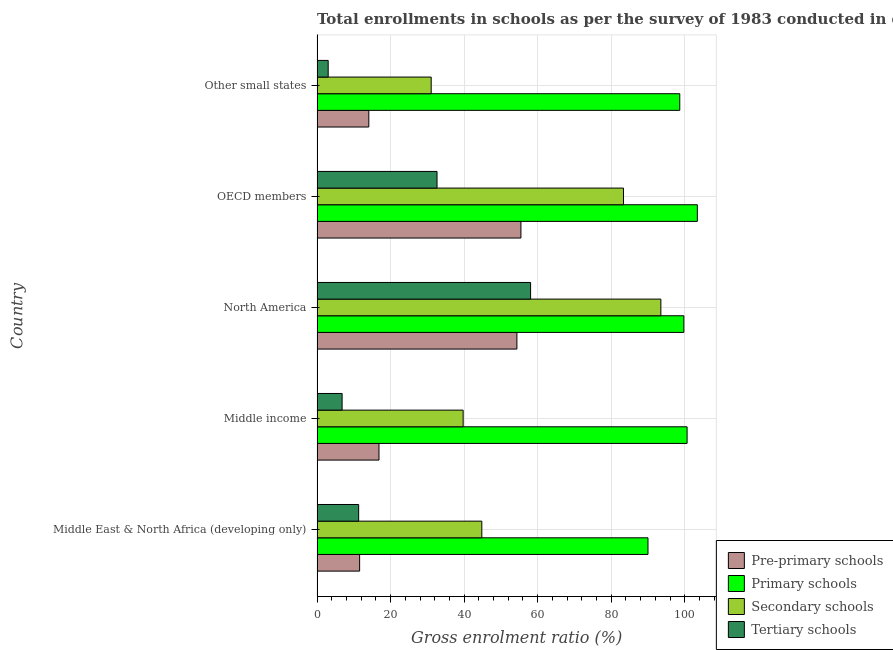How many groups of bars are there?
Make the answer very short. 5. Are the number of bars per tick equal to the number of legend labels?
Offer a very short reply. Yes. Are the number of bars on each tick of the Y-axis equal?
Provide a short and direct response. Yes. What is the label of the 1st group of bars from the top?
Your response must be concise. Other small states. What is the gross enrolment ratio in tertiary schools in Other small states?
Provide a short and direct response. 3.03. Across all countries, what is the maximum gross enrolment ratio in pre-primary schools?
Your response must be concise. 55.45. Across all countries, what is the minimum gross enrolment ratio in tertiary schools?
Keep it short and to the point. 3.03. In which country was the gross enrolment ratio in tertiary schools minimum?
Your answer should be very brief. Other small states. What is the total gross enrolment ratio in secondary schools in the graph?
Keep it short and to the point. 292.43. What is the difference between the gross enrolment ratio in tertiary schools in Middle income and that in North America?
Your answer should be very brief. -51.26. What is the difference between the gross enrolment ratio in pre-primary schools in OECD members and the gross enrolment ratio in primary schools in Middle East & North Africa (developing only)?
Give a very brief answer. -34.56. What is the average gross enrolment ratio in tertiary schools per country?
Offer a very short reply. 22.37. What is the difference between the gross enrolment ratio in secondary schools and gross enrolment ratio in primary schools in North America?
Offer a terse response. -6.25. In how many countries, is the gross enrolment ratio in tertiary schools greater than 32 %?
Keep it short and to the point. 2. What is the ratio of the gross enrolment ratio in pre-primary schools in North America to that in Other small states?
Keep it short and to the point. 3.86. Is the gross enrolment ratio in pre-primary schools in Middle income less than that in Other small states?
Make the answer very short. No. Is the difference between the gross enrolment ratio in primary schools in Middle East & North Africa (developing only) and OECD members greater than the difference between the gross enrolment ratio in secondary schools in Middle East & North Africa (developing only) and OECD members?
Make the answer very short. Yes. What is the difference between the highest and the second highest gross enrolment ratio in pre-primary schools?
Provide a succinct answer. 1.09. What is the difference between the highest and the lowest gross enrolment ratio in pre-primary schools?
Your answer should be compact. 43.87. Is the sum of the gross enrolment ratio in pre-primary schools in Middle East & North Africa (developing only) and Middle income greater than the maximum gross enrolment ratio in tertiary schools across all countries?
Ensure brevity in your answer.  No. Is it the case that in every country, the sum of the gross enrolment ratio in primary schools and gross enrolment ratio in tertiary schools is greater than the sum of gross enrolment ratio in secondary schools and gross enrolment ratio in pre-primary schools?
Ensure brevity in your answer.  No. What does the 3rd bar from the top in Middle income represents?
Offer a terse response. Primary schools. What does the 2nd bar from the bottom in North America represents?
Your response must be concise. Primary schools. Are the values on the major ticks of X-axis written in scientific E-notation?
Give a very brief answer. No. Does the graph contain grids?
Keep it short and to the point. Yes. How many legend labels are there?
Your answer should be compact. 4. How are the legend labels stacked?
Your response must be concise. Vertical. What is the title of the graph?
Your answer should be compact. Total enrollments in schools as per the survey of 1983 conducted in different countries. Does "UNPBF" appear as one of the legend labels in the graph?
Ensure brevity in your answer.  No. What is the label or title of the Y-axis?
Give a very brief answer. Country. What is the Gross enrolment ratio (%) of Pre-primary schools in Middle East & North Africa (developing only)?
Your answer should be very brief. 11.58. What is the Gross enrolment ratio (%) in Primary schools in Middle East & North Africa (developing only)?
Offer a terse response. 90. What is the Gross enrolment ratio (%) of Secondary schools in Middle East & North Africa (developing only)?
Make the answer very short. 44.81. What is the Gross enrolment ratio (%) in Tertiary schools in Middle East & North Africa (developing only)?
Your answer should be very brief. 11.32. What is the Gross enrolment ratio (%) in Pre-primary schools in Middle income?
Provide a succinct answer. 16.84. What is the Gross enrolment ratio (%) in Primary schools in Middle income?
Ensure brevity in your answer.  100.64. What is the Gross enrolment ratio (%) of Secondary schools in Middle income?
Ensure brevity in your answer.  39.73. What is the Gross enrolment ratio (%) in Tertiary schools in Middle income?
Offer a very short reply. 6.81. What is the Gross enrolment ratio (%) in Pre-primary schools in North America?
Keep it short and to the point. 54.36. What is the Gross enrolment ratio (%) in Primary schools in North America?
Provide a short and direct response. 99.76. What is the Gross enrolment ratio (%) of Secondary schools in North America?
Your answer should be very brief. 93.51. What is the Gross enrolment ratio (%) in Tertiary schools in North America?
Make the answer very short. 58.08. What is the Gross enrolment ratio (%) of Pre-primary schools in OECD members?
Provide a short and direct response. 55.45. What is the Gross enrolment ratio (%) in Primary schools in OECD members?
Provide a short and direct response. 103.43. What is the Gross enrolment ratio (%) of Secondary schools in OECD members?
Provide a succinct answer. 83.34. What is the Gross enrolment ratio (%) in Tertiary schools in OECD members?
Give a very brief answer. 32.63. What is the Gross enrolment ratio (%) of Pre-primary schools in Other small states?
Provide a short and direct response. 14.08. What is the Gross enrolment ratio (%) in Primary schools in Other small states?
Your answer should be very brief. 98.65. What is the Gross enrolment ratio (%) of Secondary schools in Other small states?
Make the answer very short. 31.04. What is the Gross enrolment ratio (%) in Tertiary schools in Other small states?
Ensure brevity in your answer.  3.03. Across all countries, what is the maximum Gross enrolment ratio (%) in Pre-primary schools?
Offer a terse response. 55.45. Across all countries, what is the maximum Gross enrolment ratio (%) in Primary schools?
Offer a terse response. 103.43. Across all countries, what is the maximum Gross enrolment ratio (%) of Secondary schools?
Your answer should be very brief. 93.51. Across all countries, what is the maximum Gross enrolment ratio (%) of Tertiary schools?
Your answer should be very brief. 58.08. Across all countries, what is the minimum Gross enrolment ratio (%) of Pre-primary schools?
Ensure brevity in your answer.  11.58. Across all countries, what is the minimum Gross enrolment ratio (%) in Primary schools?
Your response must be concise. 90. Across all countries, what is the minimum Gross enrolment ratio (%) of Secondary schools?
Your response must be concise. 31.04. Across all countries, what is the minimum Gross enrolment ratio (%) of Tertiary schools?
Give a very brief answer. 3.03. What is the total Gross enrolment ratio (%) of Pre-primary schools in the graph?
Make the answer very short. 152.3. What is the total Gross enrolment ratio (%) of Primary schools in the graph?
Your answer should be very brief. 492.48. What is the total Gross enrolment ratio (%) in Secondary schools in the graph?
Make the answer very short. 292.43. What is the total Gross enrolment ratio (%) of Tertiary schools in the graph?
Your answer should be very brief. 111.86. What is the difference between the Gross enrolment ratio (%) in Pre-primary schools in Middle East & North Africa (developing only) and that in Middle income?
Your answer should be very brief. -5.27. What is the difference between the Gross enrolment ratio (%) in Primary schools in Middle East & North Africa (developing only) and that in Middle income?
Give a very brief answer. -10.64. What is the difference between the Gross enrolment ratio (%) in Secondary schools in Middle East & North Africa (developing only) and that in Middle income?
Your response must be concise. 5.08. What is the difference between the Gross enrolment ratio (%) in Tertiary schools in Middle East & North Africa (developing only) and that in Middle income?
Provide a short and direct response. 4.5. What is the difference between the Gross enrolment ratio (%) of Pre-primary schools in Middle East & North Africa (developing only) and that in North America?
Ensure brevity in your answer.  -42.78. What is the difference between the Gross enrolment ratio (%) in Primary schools in Middle East & North Africa (developing only) and that in North America?
Provide a short and direct response. -9.75. What is the difference between the Gross enrolment ratio (%) of Secondary schools in Middle East & North Africa (developing only) and that in North America?
Your response must be concise. -48.7. What is the difference between the Gross enrolment ratio (%) in Tertiary schools in Middle East & North Africa (developing only) and that in North America?
Your answer should be compact. -46.76. What is the difference between the Gross enrolment ratio (%) of Pre-primary schools in Middle East & North Africa (developing only) and that in OECD members?
Give a very brief answer. -43.87. What is the difference between the Gross enrolment ratio (%) in Primary schools in Middle East & North Africa (developing only) and that in OECD members?
Provide a short and direct response. -13.42. What is the difference between the Gross enrolment ratio (%) of Secondary schools in Middle East & North Africa (developing only) and that in OECD members?
Provide a succinct answer. -38.53. What is the difference between the Gross enrolment ratio (%) of Tertiary schools in Middle East & North Africa (developing only) and that in OECD members?
Offer a terse response. -21.31. What is the difference between the Gross enrolment ratio (%) of Pre-primary schools in Middle East & North Africa (developing only) and that in Other small states?
Keep it short and to the point. -2.5. What is the difference between the Gross enrolment ratio (%) in Primary schools in Middle East & North Africa (developing only) and that in Other small states?
Ensure brevity in your answer.  -8.64. What is the difference between the Gross enrolment ratio (%) in Secondary schools in Middle East & North Africa (developing only) and that in Other small states?
Ensure brevity in your answer.  13.77. What is the difference between the Gross enrolment ratio (%) in Tertiary schools in Middle East & North Africa (developing only) and that in Other small states?
Your answer should be compact. 8.29. What is the difference between the Gross enrolment ratio (%) in Pre-primary schools in Middle income and that in North America?
Your answer should be compact. -37.51. What is the difference between the Gross enrolment ratio (%) in Primary schools in Middle income and that in North America?
Offer a very short reply. 0.88. What is the difference between the Gross enrolment ratio (%) of Secondary schools in Middle income and that in North America?
Offer a terse response. -53.78. What is the difference between the Gross enrolment ratio (%) of Tertiary schools in Middle income and that in North America?
Your answer should be compact. -51.26. What is the difference between the Gross enrolment ratio (%) of Pre-primary schools in Middle income and that in OECD members?
Ensure brevity in your answer.  -38.6. What is the difference between the Gross enrolment ratio (%) of Primary schools in Middle income and that in OECD members?
Your answer should be compact. -2.79. What is the difference between the Gross enrolment ratio (%) of Secondary schools in Middle income and that in OECD members?
Keep it short and to the point. -43.61. What is the difference between the Gross enrolment ratio (%) in Tertiary schools in Middle income and that in OECD members?
Provide a succinct answer. -25.82. What is the difference between the Gross enrolment ratio (%) in Pre-primary schools in Middle income and that in Other small states?
Your answer should be very brief. 2.77. What is the difference between the Gross enrolment ratio (%) of Primary schools in Middle income and that in Other small states?
Offer a terse response. 1.99. What is the difference between the Gross enrolment ratio (%) in Secondary schools in Middle income and that in Other small states?
Your answer should be very brief. 8.69. What is the difference between the Gross enrolment ratio (%) in Tertiary schools in Middle income and that in Other small states?
Give a very brief answer. 3.79. What is the difference between the Gross enrolment ratio (%) of Pre-primary schools in North America and that in OECD members?
Give a very brief answer. -1.09. What is the difference between the Gross enrolment ratio (%) of Primary schools in North America and that in OECD members?
Provide a succinct answer. -3.67. What is the difference between the Gross enrolment ratio (%) of Secondary schools in North America and that in OECD members?
Offer a terse response. 10.17. What is the difference between the Gross enrolment ratio (%) in Tertiary schools in North America and that in OECD members?
Offer a terse response. 25.45. What is the difference between the Gross enrolment ratio (%) of Pre-primary schools in North America and that in Other small states?
Provide a succinct answer. 40.28. What is the difference between the Gross enrolment ratio (%) in Primary schools in North America and that in Other small states?
Your response must be concise. 1.11. What is the difference between the Gross enrolment ratio (%) of Secondary schools in North America and that in Other small states?
Provide a succinct answer. 62.46. What is the difference between the Gross enrolment ratio (%) of Tertiary schools in North America and that in Other small states?
Your answer should be very brief. 55.05. What is the difference between the Gross enrolment ratio (%) in Pre-primary schools in OECD members and that in Other small states?
Your response must be concise. 41.37. What is the difference between the Gross enrolment ratio (%) of Primary schools in OECD members and that in Other small states?
Offer a very short reply. 4.78. What is the difference between the Gross enrolment ratio (%) in Secondary schools in OECD members and that in Other small states?
Your response must be concise. 52.3. What is the difference between the Gross enrolment ratio (%) of Tertiary schools in OECD members and that in Other small states?
Keep it short and to the point. 29.6. What is the difference between the Gross enrolment ratio (%) of Pre-primary schools in Middle East & North Africa (developing only) and the Gross enrolment ratio (%) of Primary schools in Middle income?
Make the answer very short. -89.06. What is the difference between the Gross enrolment ratio (%) in Pre-primary schools in Middle East & North Africa (developing only) and the Gross enrolment ratio (%) in Secondary schools in Middle income?
Give a very brief answer. -28.15. What is the difference between the Gross enrolment ratio (%) in Pre-primary schools in Middle East & North Africa (developing only) and the Gross enrolment ratio (%) in Tertiary schools in Middle income?
Give a very brief answer. 4.76. What is the difference between the Gross enrolment ratio (%) of Primary schools in Middle East & North Africa (developing only) and the Gross enrolment ratio (%) of Secondary schools in Middle income?
Your answer should be compact. 50.27. What is the difference between the Gross enrolment ratio (%) of Primary schools in Middle East & North Africa (developing only) and the Gross enrolment ratio (%) of Tertiary schools in Middle income?
Provide a succinct answer. 83.19. What is the difference between the Gross enrolment ratio (%) in Secondary schools in Middle East & North Africa (developing only) and the Gross enrolment ratio (%) in Tertiary schools in Middle income?
Provide a succinct answer. 38. What is the difference between the Gross enrolment ratio (%) in Pre-primary schools in Middle East & North Africa (developing only) and the Gross enrolment ratio (%) in Primary schools in North America?
Make the answer very short. -88.18. What is the difference between the Gross enrolment ratio (%) of Pre-primary schools in Middle East & North Africa (developing only) and the Gross enrolment ratio (%) of Secondary schools in North America?
Your response must be concise. -81.93. What is the difference between the Gross enrolment ratio (%) of Pre-primary schools in Middle East & North Africa (developing only) and the Gross enrolment ratio (%) of Tertiary schools in North America?
Your answer should be compact. -46.5. What is the difference between the Gross enrolment ratio (%) in Primary schools in Middle East & North Africa (developing only) and the Gross enrolment ratio (%) in Secondary schools in North America?
Your response must be concise. -3.5. What is the difference between the Gross enrolment ratio (%) of Primary schools in Middle East & North Africa (developing only) and the Gross enrolment ratio (%) of Tertiary schools in North America?
Provide a short and direct response. 31.93. What is the difference between the Gross enrolment ratio (%) of Secondary schools in Middle East & North Africa (developing only) and the Gross enrolment ratio (%) of Tertiary schools in North America?
Your answer should be compact. -13.27. What is the difference between the Gross enrolment ratio (%) in Pre-primary schools in Middle East & North Africa (developing only) and the Gross enrolment ratio (%) in Primary schools in OECD members?
Keep it short and to the point. -91.85. What is the difference between the Gross enrolment ratio (%) of Pre-primary schools in Middle East & North Africa (developing only) and the Gross enrolment ratio (%) of Secondary schools in OECD members?
Your answer should be very brief. -71.76. What is the difference between the Gross enrolment ratio (%) in Pre-primary schools in Middle East & North Africa (developing only) and the Gross enrolment ratio (%) in Tertiary schools in OECD members?
Make the answer very short. -21.05. What is the difference between the Gross enrolment ratio (%) in Primary schools in Middle East & North Africa (developing only) and the Gross enrolment ratio (%) in Secondary schools in OECD members?
Provide a short and direct response. 6.66. What is the difference between the Gross enrolment ratio (%) in Primary schools in Middle East & North Africa (developing only) and the Gross enrolment ratio (%) in Tertiary schools in OECD members?
Make the answer very short. 57.38. What is the difference between the Gross enrolment ratio (%) of Secondary schools in Middle East & North Africa (developing only) and the Gross enrolment ratio (%) of Tertiary schools in OECD members?
Make the answer very short. 12.18. What is the difference between the Gross enrolment ratio (%) of Pre-primary schools in Middle East & North Africa (developing only) and the Gross enrolment ratio (%) of Primary schools in Other small states?
Give a very brief answer. -87.07. What is the difference between the Gross enrolment ratio (%) in Pre-primary schools in Middle East & North Africa (developing only) and the Gross enrolment ratio (%) in Secondary schools in Other small states?
Your answer should be compact. -19.47. What is the difference between the Gross enrolment ratio (%) in Pre-primary schools in Middle East & North Africa (developing only) and the Gross enrolment ratio (%) in Tertiary schools in Other small states?
Your answer should be very brief. 8.55. What is the difference between the Gross enrolment ratio (%) in Primary schools in Middle East & North Africa (developing only) and the Gross enrolment ratio (%) in Secondary schools in Other small states?
Keep it short and to the point. 58.96. What is the difference between the Gross enrolment ratio (%) of Primary schools in Middle East & North Africa (developing only) and the Gross enrolment ratio (%) of Tertiary schools in Other small states?
Give a very brief answer. 86.98. What is the difference between the Gross enrolment ratio (%) of Secondary schools in Middle East & North Africa (developing only) and the Gross enrolment ratio (%) of Tertiary schools in Other small states?
Your response must be concise. 41.78. What is the difference between the Gross enrolment ratio (%) in Pre-primary schools in Middle income and the Gross enrolment ratio (%) in Primary schools in North America?
Keep it short and to the point. -82.91. What is the difference between the Gross enrolment ratio (%) in Pre-primary schools in Middle income and the Gross enrolment ratio (%) in Secondary schools in North America?
Your answer should be compact. -76.66. What is the difference between the Gross enrolment ratio (%) of Pre-primary schools in Middle income and the Gross enrolment ratio (%) of Tertiary schools in North America?
Keep it short and to the point. -41.23. What is the difference between the Gross enrolment ratio (%) of Primary schools in Middle income and the Gross enrolment ratio (%) of Secondary schools in North America?
Offer a very short reply. 7.13. What is the difference between the Gross enrolment ratio (%) of Primary schools in Middle income and the Gross enrolment ratio (%) of Tertiary schools in North America?
Your answer should be compact. 42.56. What is the difference between the Gross enrolment ratio (%) in Secondary schools in Middle income and the Gross enrolment ratio (%) in Tertiary schools in North America?
Offer a terse response. -18.34. What is the difference between the Gross enrolment ratio (%) of Pre-primary schools in Middle income and the Gross enrolment ratio (%) of Primary schools in OECD members?
Offer a very short reply. -86.58. What is the difference between the Gross enrolment ratio (%) in Pre-primary schools in Middle income and the Gross enrolment ratio (%) in Secondary schools in OECD members?
Your answer should be very brief. -66.5. What is the difference between the Gross enrolment ratio (%) in Pre-primary schools in Middle income and the Gross enrolment ratio (%) in Tertiary schools in OECD members?
Provide a succinct answer. -15.78. What is the difference between the Gross enrolment ratio (%) of Primary schools in Middle income and the Gross enrolment ratio (%) of Secondary schools in OECD members?
Give a very brief answer. 17.3. What is the difference between the Gross enrolment ratio (%) in Primary schools in Middle income and the Gross enrolment ratio (%) in Tertiary schools in OECD members?
Offer a terse response. 68.01. What is the difference between the Gross enrolment ratio (%) in Secondary schools in Middle income and the Gross enrolment ratio (%) in Tertiary schools in OECD members?
Give a very brief answer. 7.1. What is the difference between the Gross enrolment ratio (%) of Pre-primary schools in Middle income and the Gross enrolment ratio (%) of Primary schools in Other small states?
Keep it short and to the point. -81.8. What is the difference between the Gross enrolment ratio (%) of Pre-primary schools in Middle income and the Gross enrolment ratio (%) of Secondary schools in Other small states?
Provide a succinct answer. -14.2. What is the difference between the Gross enrolment ratio (%) in Pre-primary schools in Middle income and the Gross enrolment ratio (%) in Tertiary schools in Other small states?
Provide a short and direct response. 13.82. What is the difference between the Gross enrolment ratio (%) in Primary schools in Middle income and the Gross enrolment ratio (%) in Secondary schools in Other small states?
Make the answer very short. 69.6. What is the difference between the Gross enrolment ratio (%) in Primary schools in Middle income and the Gross enrolment ratio (%) in Tertiary schools in Other small states?
Give a very brief answer. 97.61. What is the difference between the Gross enrolment ratio (%) in Secondary schools in Middle income and the Gross enrolment ratio (%) in Tertiary schools in Other small states?
Ensure brevity in your answer.  36.7. What is the difference between the Gross enrolment ratio (%) in Pre-primary schools in North America and the Gross enrolment ratio (%) in Primary schools in OECD members?
Provide a short and direct response. -49.07. What is the difference between the Gross enrolment ratio (%) of Pre-primary schools in North America and the Gross enrolment ratio (%) of Secondary schools in OECD members?
Your response must be concise. -28.98. What is the difference between the Gross enrolment ratio (%) of Pre-primary schools in North America and the Gross enrolment ratio (%) of Tertiary schools in OECD members?
Make the answer very short. 21.73. What is the difference between the Gross enrolment ratio (%) of Primary schools in North America and the Gross enrolment ratio (%) of Secondary schools in OECD members?
Make the answer very short. 16.42. What is the difference between the Gross enrolment ratio (%) in Primary schools in North America and the Gross enrolment ratio (%) in Tertiary schools in OECD members?
Give a very brief answer. 67.13. What is the difference between the Gross enrolment ratio (%) in Secondary schools in North America and the Gross enrolment ratio (%) in Tertiary schools in OECD members?
Ensure brevity in your answer.  60.88. What is the difference between the Gross enrolment ratio (%) in Pre-primary schools in North America and the Gross enrolment ratio (%) in Primary schools in Other small states?
Your response must be concise. -44.29. What is the difference between the Gross enrolment ratio (%) of Pre-primary schools in North America and the Gross enrolment ratio (%) of Secondary schools in Other small states?
Keep it short and to the point. 23.31. What is the difference between the Gross enrolment ratio (%) in Pre-primary schools in North America and the Gross enrolment ratio (%) in Tertiary schools in Other small states?
Your answer should be very brief. 51.33. What is the difference between the Gross enrolment ratio (%) in Primary schools in North America and the Gross enrolment ratio (%) in Secondary schools in Other small states?
Offer a terse response. 68.71. What is the difference between the Gross enrolment ratio (%) of Primary schools in North America and the Gross enrolment ratio (%) of Tertiary schools in Other small states?
Offer a terse response. 96.73. What is the difference between the Gross enrolment ratio (%) of Secondary schools in North America and the Gross enrolment ratio (%) of Tertiary schools in Other small states?
Provide a succinct answer. 90.48. What is the difference between the Gross enrolment ratio (%) of Pre-primary schools in OECD members and the Gross enrolment ratio (%) of Primary schools in Other small states?
Provide a succinct answer. -43.2. What is the difference between the Gross enrolment ratio (%) in Pre-primary schools in OECD members and the Gross enrolment ratio (%) in Secondary schools in Other small states?
Your answer should be very brief. 24.4. What is the difference between the Gross enrolment ratio (%) in Pre-primary schools in OECD members and the Gross enrolment ratio (%) in Tertiary schools in Other small states?
Your answer should be very brief. 52.42. What is the difference between the Gross enrolment ratio (%) of Primary schools in OECD members and the Gross enrolment ratio (%) of Secondary schools in Other small states?
Provide a succinct answer. 72.38. What is the difference between the Gross enrolment ratio (%) of Primary schools in OECD members and the Gross enrolment ratio (%) of Tertiary schools in Other small states?
Your answer should be very brief. 100.4. What is the difference between the Gross enrolment ratio (%) of Secondary schools in OECD members and the Gross enrolment ratio (%) of Tertiary schools in Other small states?
Ensure brevity in your answer.  80.31. What is the average Gross enrolment ratio (%) in Pre-primary schools per country?
Your response must be concise. 30.46. What is the average Gross enrolment ratio (%) of Primary schools per country?
Give a very brief answer. 98.5. What is the average Gross enrolment ratio (%) of Secondary schools per country?
Provide a short and direct response. 58.49. What is the average Gross enrolment ratio (%) in Tertiary schools per country?
Keep it short and to the point. 22.37. What is the difference between the Gross enrolment ratio (%) of Pre-primary schools and Gross enrolment ratio (%) of Primary schools in Middle East & North Africa (developing only)?
Offer a terse response. -78.43. What is the difference between the Gross enrolment ratio (%) in Pre-primary schools and Gross enrolment ratio (%) in Secondary schools in Middle East & North Africa (developing only)?
Your answer should be compact. -33.23. What is the difference between the Gross enrolment ratio (%) in Pre-primary schools and Gross enrolment ratio (%) in Tertiary schools in Middle East & North Africa (developing only)?
Keep it short and to the point. 0.26. What is the difference between the Gross enrolment ratio (%) in Primary schools and Gross enrolment ratio (%) in Secondary schools in Middle East & North Africa (developing only)?
Keep it short and to the point. 45.19. What is the difference between the Gross enrolment ratio (%) of Primary schools and Gross enrolment ratio (%) of Tertiary schools in Middle East & North Africa (developing only)?
Offer a terse response. 78.69. What is the difference between the Gross enrolment ratio (%) in Secondary schools and Gross enrolment ratio (%) in Tertiary schools in Middle East & North Africa (developing only)?
Give a very brief answer. 33.49. What is the difference between the Gross enrolment ratio (%) of Pre-primary schools and Gross enrolment ratio (%) of Primary schools in Middle income?
Provide a succinct answer. -83.8. What is the difference between the Gross enrolment ratio (%) in Pre-primary schools and Gross enrolment ratio (%) in Secondary schools in Middle income?
Make the answer very short. -22.89. What is the difference between the Gross enrolment ratio (%) of Pre-primary schools and Gross enrolment ratio (%) of Tertiary schools in Middle income?
Your answer should be compact. 10.03. What is the difference between the Gross enrolment ratio (%) of Primary schools and Gross enrolment ratio (%) of Secondary schools in Middle income?
Make the answer very short. 60.91. What is the difference between the Gross enrolment ratio (%) of Primary schools and Gross enrolment ratio (%) of Tertiary schools in Middle income?
Your answer should be very brief. 93.83. What is the difference between the Gross enrolment ratio (%) in Secondary schools and Gross enrolment ratio (%) in Tertiary schools in Middle income?
Make the answer very short. 32.92. What is the difference between the Gross enrolment ratio (%) of Pre-primary schools and Gross enrolment ratio (%) of Primary schools in North America?
Provide a short and direct response. -45.4. What is the difference between the Gross enrolment ratio (%) of Pre-primary schools and Gross enrolment ratio (%) of Secondary schools in North America?
Provide a short and direct response. -39.15. What is the difference between the Gross enrolment ratio (%) in Pre-primary schools and Gross enrolment ratio (%) in Tertiary schools in North America?
Your answer should be compact. -3.72. What is the difference between the Gross enrolment ratio (%) of Primary schools and Gross enrolment ratio (%) of Secondary schools in North America?
Provide a succinct answer. 6.25. What is the difference between the Gross enrolment ratio (%) of Primary schools and Gross enrolment ratio (%) of Tertiary schools in North America?
Offer a very short reply. 41.68. What is the difference between the Gross enrolment ratio (%) of Secondary schools and Gross enrolment ratio (%) of Tertiary schools in North America?
Make the answer very short. 35.43. What is the difference between the Gross enrolment ratio (%) in Pre-primary schools and Gross enrolment ratio (%) in Primary schools in OECD members?
Your response must be concise. -47.98. What is the difference between the Gross enrolment ratio (%) of Pre-primary schools and Gross enrolment ratio (%) of Secondary schools in OECD members?
Ensure brevity in your answer.  -27.89. What is the difference between the Gross enrolment ratio (%) in Pre-primary schools and Gross enrolment ratio (%) in Tertiary schools in OECD members?
Provide a succinct answer. 22.82. What is the difference between the Gross enrolment ratio (%) in Primary schools and Gross enrolment ratio (%) in Secondary schools in OECD members?
Your answer should be compact. 20.09. What is the difference between the Gross enrolment ratio (%) of Primary schools and Gross enrolment ratio (%) of Tertiary schools in OECD members?
Offer a very short reply. 70.8. What is the difference between the Gross enrolment ratio (%) of Secondary schools and Gross enrolment ratio (%) of Tertiary schools in OECD members?
Offer a terse response. 50.71. What is the difference between the Gross enrolment ratio (%) of Pre-primary schools and Gross enrolment ratio (%) of Primary schools in Other small states?
Give a very brief answer. -84.57. What is the difference between the Gross enrolment ratio (%) of Pre-primary schools and Gross enrolment ratio (%) of Secondary schools in Other small states?
Your answer should be compact. -16.96. What is the difference between the Gross enrolment ratio (%) in Pre-primary schools and Gross enrolment ratio (%) in Tertiary schools in Other small states?
Provide a succinct answer. 11.05. What is the difference between the Gross enrolment ratio (%) of Primary schools and Gross enrolment ratio (%) of Secondary schools in Other small states?
Offer a very short reply. 67.6. What is the difference between the Gross enrolment ratio (%) of Primary schools and Gross enrolment ratio (%) of Tertiary schools in Other small states?
Keep it short and to the point. 95.62. What is the difference between the Gross enrolment ratio (%) of Secondary schools and Gross enrolment ratio (%) of Tertiary schools in Other small states?
Offer a very short reply. 28.02. What is the ratio of the Gross enrolment ratio (%) of Pre-primary schools in Middle East & North Africa (developing only) to that in Middle income?
Offer a very short reply. 0.69. What is the ratio of the Gross enrolment ratio (%) in Primary schools in Middle East & North Africa (developing only) to that in Middle income?
Offer a terse response. 0.89. What is the ratio of the Gross enrolment ratio (%) in Secondary schools in Middle East & North Africa (developing only) to that in Middle income?
Provide a short and direct response. 1.13. What is the ratio of the Gross enrolment ratio (%) in Tertiary schools in Middle East & North Africa (developing only) to that in Middle income?
Provide a short and direct response. 1.66. What is the ratio of the Gross enrolment ratio (%) of Pre-primary schools in Middle East & North Africa (developing only) to that in North America?
Keep it short and to the point. 0.21. What is the ratio of the Gross enrolment ratio (%) in Primary schools in Middle East & North Africa (developing only) to that in North America?
Ensure brevity in your answer.  0.9. What is the ratio of the Gross enrolment ratio (%) of Secondary schools in Middle East & North Africa (developing only) to that in North America?
Provide a short and direct response. 0.48. What is the ratio of the Gross enrolment ratio (%) in Tertiary schools in Middle East & North Africa (developing only) to that in North America?
Your answer should be very brief. 0.19. What is the ratio of the Gross enrolment ratio (%) of Pre-primary schools in Middle East & North Africa (developing only) to that in OECD members?
Ensure brevity in your answer.  0.21. What is the ratio of the Gross enrolment ratio (%) in Primary schools in Middle East & North Africa (developing only) to that in OECD members?
Offer a very short reply. 0.87. What is the ratio of the Gross enrolment ratio (%) in Secondary schools in Middle East & North Africa (developing only) to that in OECD members?
Keep it short and to the point. 0.54. What is the ratio of the Gross enrolment ratio (%) of Tertiary schools in Middle East & North Africa (developing only) to that in OECD members?
Your response must be concise. 0.35. What is the ratio of the Gross enrolment ratio (%) of Pre-primary schools in Middle East & North Africa (developing only) to that in Other small states?
Keep it short and to the point. 0.82. What is the ratio of the Gross enrolment ratio (%) of Primary schools in Middle East & North Africa (developing only) to that in Other small states?
Offer a terse response. 0.91. What is the ratio of the Gross enrolment ratio (%) of Secondary schools in Middle East & North Africa (developing only) to that in Other small states?
Offer a terse response. 1.44. What is the ratio of the Gross enrolment ratio (%) in Tertiary schools in Middle East & North Africa (developing only) to that in Other small states?
Offer a very short reply. 3.74. What is the ratio of the Gross enrolment ratio (%) in Pre-primary schools in Middle income to that in North America?
Offer a very short reply. 0.31. What is the ratio of the Gross enrolment ratio (%) in Primary schools in Middle income to that in North America?
Ensure brevity in your answer.  1.01. What is the ratio of the Gross enrolment ratio (%) in Secondary schools in Middle income to that in North America?
Keep it short and to the point. 0.42. What is the ratio of the Gross enrolment ratio (%) of Tertiary schools in Middle income to that in North America?
Offer a very short reply. 0.12. What is the ratio of the Gross enrolment ratio (%) in Pre-primary schools in Middle income to that in OECD members?
Make the answer very short. 0.3. What is the ratio of the Gross enrolment ratio (%) in Secondary schools in Middle income to that in OECD members?
Your response must be concise. 0.48. What is the ratio of the Gross enrolment ratio (%) of Tertiary schools in Middle income to that in OECD members?
Make the answer very short. 0.21. What is the ratio of the Gross enrolment ratio (%) in Pre-primary schools in Middle income to that in Other small states?
Your response must be concise. 1.2. What is the ratio of the Gross enrolment ratio (%) in Primary schools in Middle income to that in Other small states?
Provide a succinct answer. 1.02. What is the ratio of the Gross enrolment ratio (%) in Secondary schools in Middle income to that in Other small states?
Make the answer very short. 1.28. What is the ratio of the Gross enrolment ratio (%) in Tertiary schools in Middle income to that in Other small states?
Provide a short and direct response. 2.25. What is the ratio of the Gross enrolment ratio (%) of Pre-primary schools in North America to that in OECD members?
Your answer should be compact. 0.98. What is the ratio of the Gross enrolment ratio (%) in Primary schools in North America to that in OECD members?
Your answer should be compact. 0.96. What is the ratio of the Gross enrolment ratio (%) of Secondary schools in North America to that in OECD members?
Provide a short and direct response. 1.12. What is the ratio of the Gross enrolment ratio (%) of Tertiary schools in North America to that in OECD members?
Give a very brief answer. 1.78. What is the ratio of the Gross enrolment ratio (%) of Pre-primary schools in North America to that in Other small states?
Ensure brevity in your answer.  3.86. What is the ratio of the Gross enrolment ratio (%) in Primary schools in North America to that in Other small states?
Your answer should be compact. 1.01. What is the ratio of the Gross enrolment ratio (%) in Secondary schools in North America to that in Other small states?
Your answer should be compact. 3.01. What is the ratio of the Gross enrolment ratio (%) of Tertiary schools in North America to that in Other small states?
Make the answer very short. 19.18. What is the ratio of the Gross enrolment ratio (%) in Pre-primary schools in OECD members to that in Other small states?
Provide a succinct answer. 3.94. What is the ratio of the Gross enrolment ratio (%) of Primary schools in OECD members to that in Other small states?
Provide a short and direct response. 1.05. What is the ratio of the Gross enrolment ratio (%) in Secondary schools in OECD members to that in Other small states?
Ensure brevity in your answer.  2.68. What is the ratio of the Gross enrolment ratio (%) of Tertiary schools in OECD members to that in Other small states?
Provide a short and direct response. 10.78. What is the difference between the highest and the second highest Gross enrolment ratio (%) in Pre-primary schools?
Your answer should be very brief. 1.09. What is the difference between the highest and the second highest Gross enrolment ratio (%) in Primary schools?
Provide a succinct answer. 2.79. What is the difference between the highest and the second highest Gross enrolment ratio (%) in Secondary schools?
Your response must be concise. 10.17. What is the difference between the highest and the second highest Gross enrolment ratio (%) of Tertiary schools?
Offer a terse response. 25.45. What is the difference between the highest and the lowest Gross enrolment ratio (%) of Pre-primary schools?
Your response must be concise. 43.87. What is the difference between the highest and the lowest Gross enrolment ratio (%) of Primary schools?
Make the answer very short. 13.42. What is the difference between the highest and the lowest Gross enrolment ratio (%) of Secondary schools?
Provide a short and direct response. 62.46. What is the difference between the highest and the lowest Gross enrolment ratio (%) in Tertiary schools?
Make the answer very short. 55.05. 